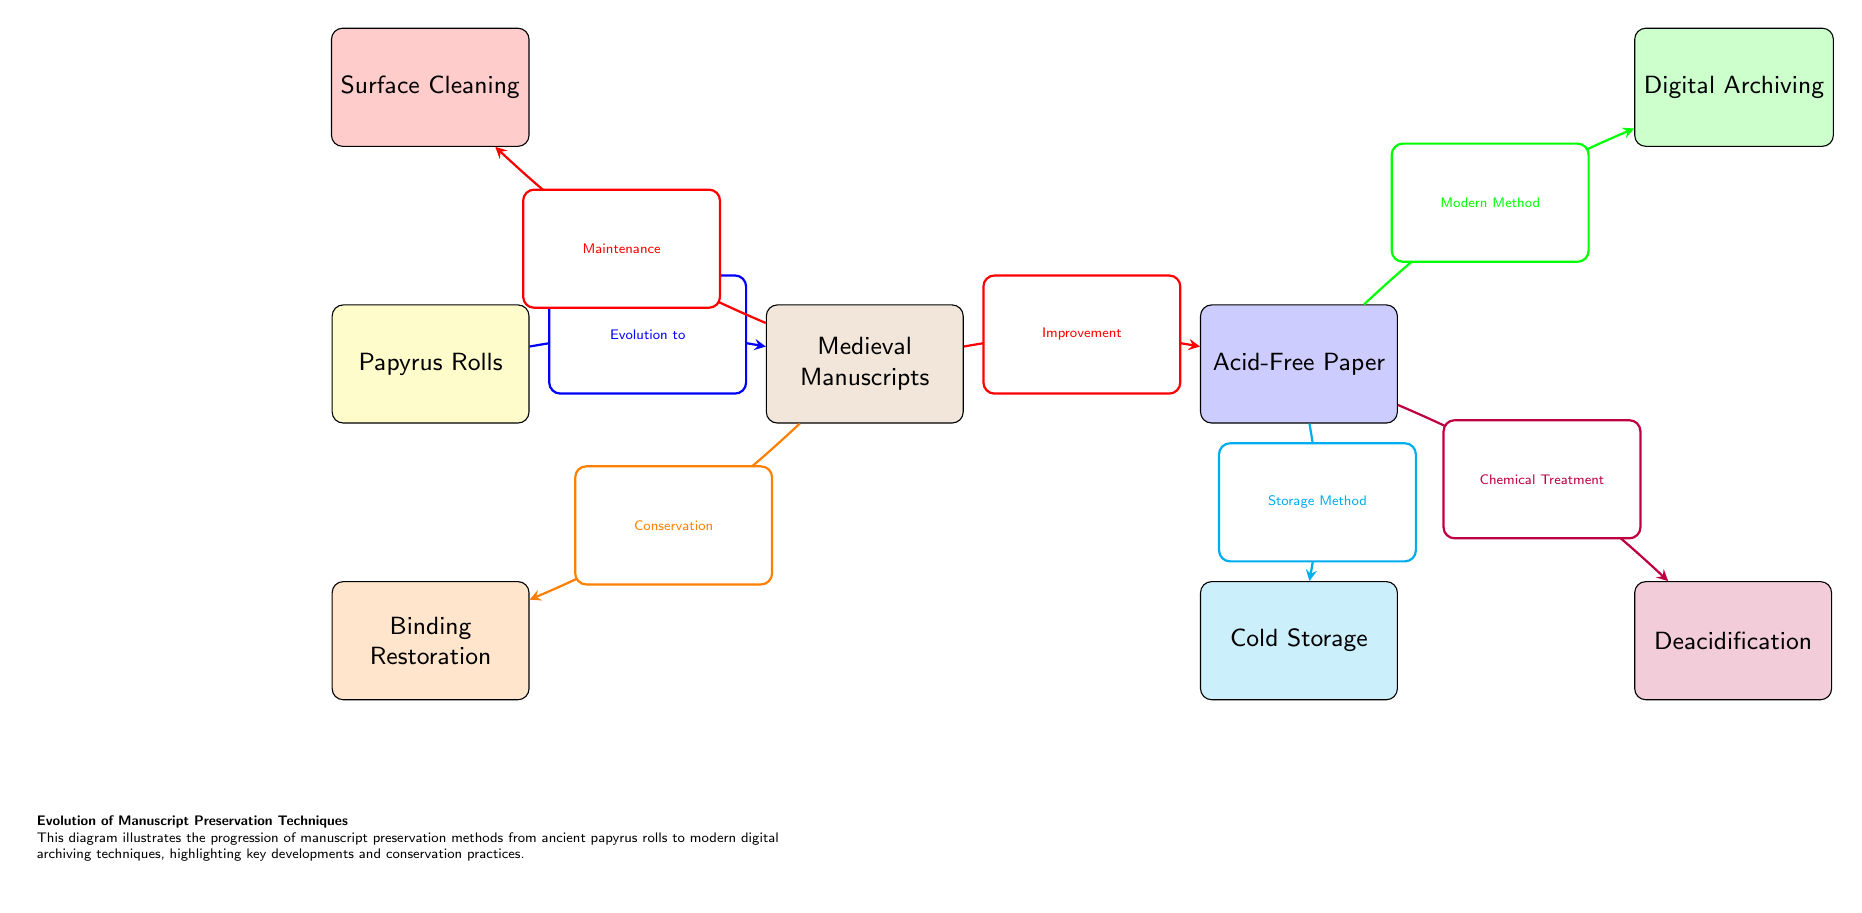What are the first manuscript preservation techniques illustrated in the diagram? The diagram begins with "Papyrus Rolls" as the initial technique for manuscript preservation, representing the earliest method used in ancient times.
Answer: Papyrus Rolls How many key preservation methods are presented in the diagram? The diagram displays a total of six nodes that represent different manuscript preservation methods, indicating the evolution and variety of techniques over time.
Answer: Six What method follows "Medieval Manuscripts" in the timeline? After "Medieval Manuscripts," the diagram connects to "Acid-Free Paper," showing a progression from medieval practices to more modern materials used in preservation.
Answer: Acid-Free Paper Which two methods are linked to "Acid-Free Paper"? The diagram illustrates that "Acid-Free Paper" leads both to "Deacidification" and "Cold Storage," indicating different approaches to preservation stemming from the use of acid-free materials.
Answer: Deacidification and Cold Storage What does the arrow from "Acid-Free Paper" to "Digital Archiving" represent? The arrow indicates the relationship labeled "Modern Method," signifying that digital archiving is a contemporary advancement in preservation techniques stemming from the use of acid-free paper.
Answer: Modern Method Which techniques are directly associated with "Medieval Manuscripts"? "Medieval Manuscripts" is directly associated with "Binding Restoration" and "Surface Cleaning," representing specific conservation practices developed during the medieval period.
Answer: Binding Restoration and Surface Cleaning Why is "Deacidification" important in manuscript preservation? "Deacidification" is important because it is a chemical treatment that helps to neutralize acidity in paper, preserving the longevity and integrity of manuscripts, particularly those made from acid-free paper.
Answer: Chemical Treatment What does the legend in the diagram explain? The legend provides context for understanding the diagram's purpose and summarizes the progression of manuscript preservation techniques over centuries, including key developments and conservation practices.
Answer: Evolution of Manuscript Preservation Techniques How does "Cold Storage" relate to "Acid-Free Paper"? "Cold Storage" is connected to "Acid-Free Paper" through the label "Storage Method," highlighting an evolved practice for storing manuscripts that take advantage of acid-free materials to enhance preservation.
Answer: Storage Method 